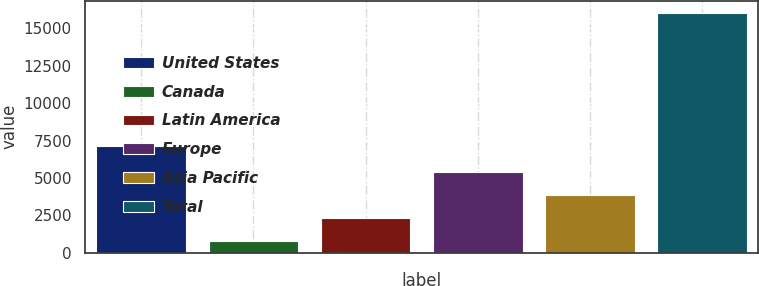Convert chart to OTSL. <chart><loc_0><loc_0><loc_500><loc_500><bar_chart><fcel>United States<fcel>Canada<fcel>Latin America<fcel>Europe<fcel>Asia Pacific<fcel>Total<nl><fcel>7165<fcel>815<fcel>2338.4<fcel>5385.2<fcel>3861.8<fcel>16049<nl></chart> 